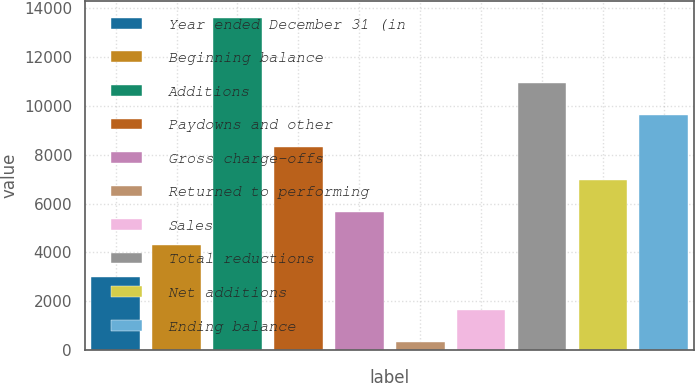<chart> <loc_0><loc_0><loc_500><loc_500><bar_chart><fcel>Year ended December 31 (in<fcel>Beginning balance<fcel>Additions<fcel>Paydowns and other<fcel>Gross charge-offs<fcel>Returned to performing<fcel>Sales<fcel>Total reductions<fcel>Net additions<fcel>Ending balance<nl><fcel>2991<fcel>4316<fcel>13591<fcel>8291<fcel>5641<fcel>341<fcel>1666<fcel>10941<fcel>6966<fcel>9616<nl></chart> 